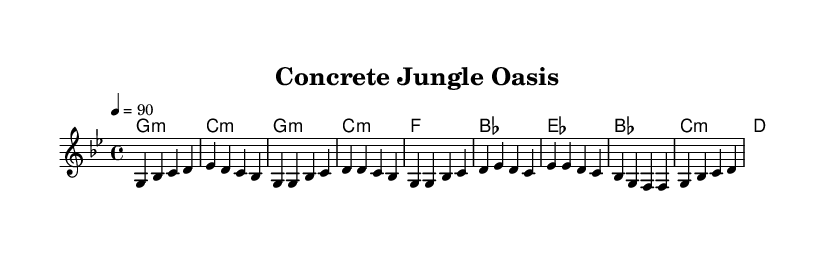What is the key signature of this music? The key signature is G minor, indicated by the presence of two flats (B flat and E flat) in the key signature.
Answer: G minor What is the time signature of this music? The time signature is indicated as 4/4 at the beginning of the score, meaning there are four beats in each measure.
Answer: 4/4 What is the tempo marking of this piece? The tempo marking is indicated as quarter note equals 90, meaning that each quarter note should be played at a speed of 90 beats per minute.
Answer: 90 How many measures are in the melody? To find the total measures, we can count each separated group of four beats (or notes) in the melody. In this case, there are 8 measures present in the melody section.
Answer: 8 What is the theme of the song as reflected in the lyrics? The lyrics emphasize the contrast between urban development and nature, highlighting the importance of green spaces and life within urban settings. This is evident through phrases about "green spaces" and "urban forests."
Answer: Importance of green spaces What is the chord progression in the chorus? To identify the chord progression, we look at the harmonies indicated along with the lyrics. The chorus features the chords E flat, B flat, C minor, and D, showing a specific progression that supports the melody.
Answer: E flat, B flat, C minor, D How does reggae music influence the rhythm of this piece? The rhythm of reggae typically emphasizes the offbeat, which can be felt in the timing of the melody and harmonies. The laid-back groove of the piece aligns with traditional reggae rhythms, giving it a distinct feel.
Answer: Offbeat rhythm influence 